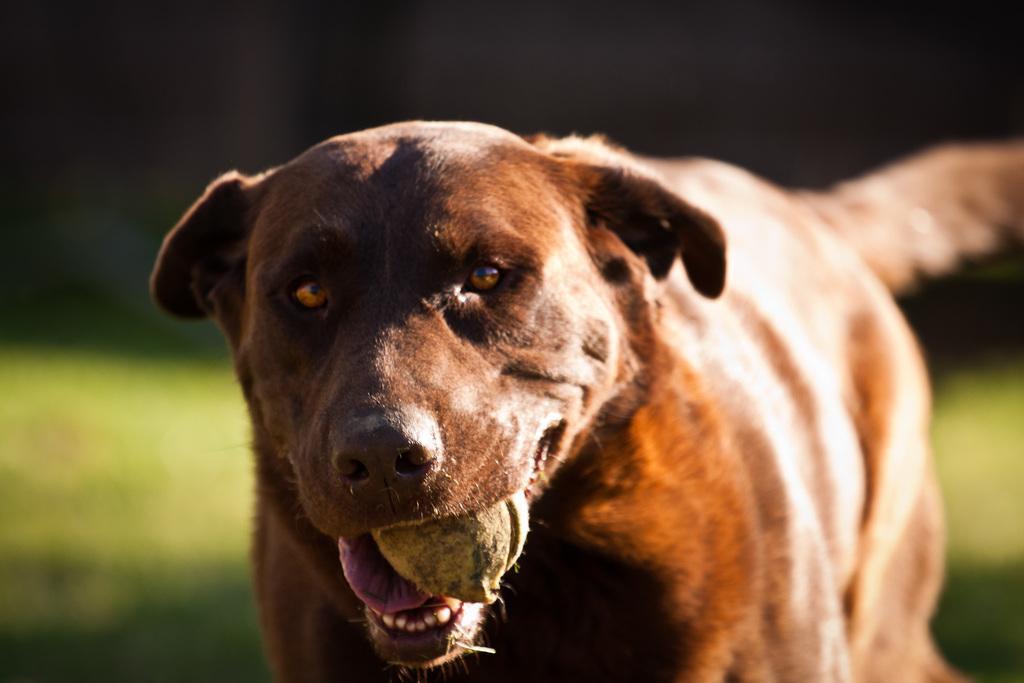Could you give a brief overview of what you see in this image? In this image there is a dog. There is an object in its mouth. Behind it there's grass on the ground. The background is blurry. 